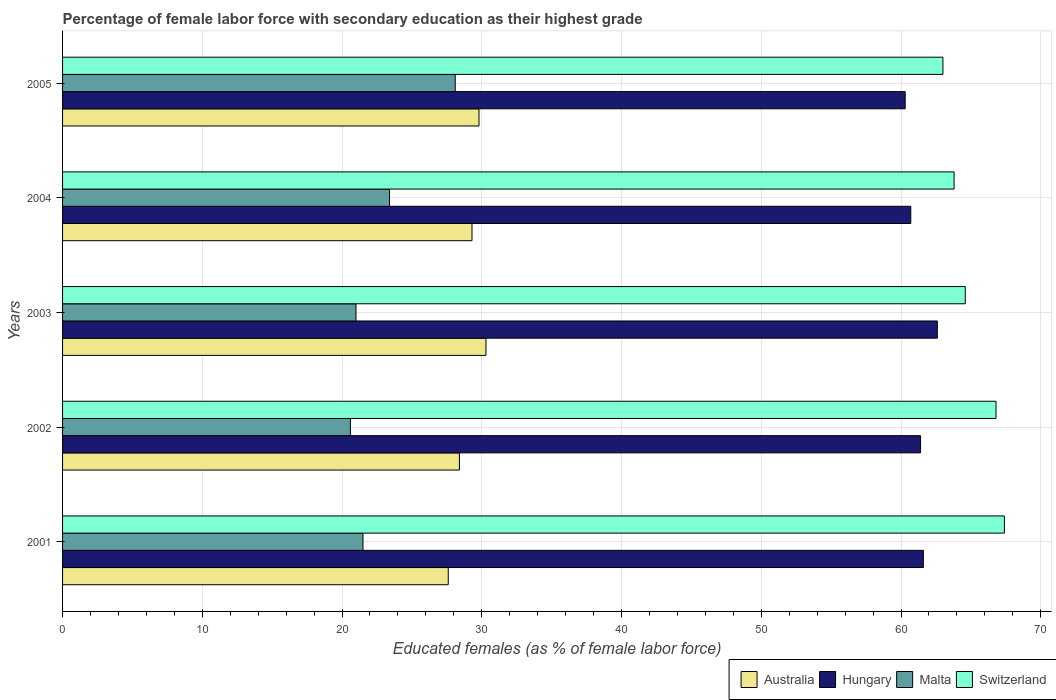Are the number of bars on each tick of the Y-axis equal?
Make the answer very short. Yes. How many bars are there on the 1st tick from the top?
Provide a short and direct response. 4. How many bars are there on the 4th tick from the bottom?
Your response must be concise. 4. What is the percentage of female labor force with secondary education in Hungary in 2005?
Your answer should be compact. 60.3. Across all years, what is the maximum percentage of female labor force with secondary education in Australia?
Make the answer very short. 30.3. In which year was the percentage of female labor force with secondary education in Switzerland maximum?
Ensure brevity in your answer.  2001. What is the total percentage of female labor force with secondary education in Malta in the graph?
Keep it short and to the point. 114.6. What is the difference between the percentage of female labor force with secondary education in Hungary in 2003 and that in 2005?
Your answer should be compact. 2.3. What is the difference between the percentage of female labor force with secondary education in Hungary in 2001 and the percentage of female labor force with secondary education in Australia in 2002?
Offer a terse response. 33.2. What is the average percentage of female labor force with secondary education in Hungary per year?
Provide a short and direct response. 61.32. In the year 2001, what is the difference between the percentage of female labor force with secondary education in Switzerland and percentage of female labor force with secondary education in Australia?
Your answer should be compact. 39.8. What is the ratio of the percentage of female labor force with secondary education in Australia in 2001 to that in 2003?
Offer a terse response. 0.91. Is the difference between the percentage of female labor force with secondary education in Switzerland in 2002 and 2004 greater than the difference between the percentage of female labor force with secondary education in Australia in 2002 and 2004?
Keep it short and to the point. Yes. What is the difference between the highest and the lowest percentage of female labor force with secondary education in Australia?
Make the answer very short. 2.7. In how many years, is the percentage of female labor force with secondary education in Australia greater than the average percentage of female labor force with secondary education in Australia taken over all years?
Your answer should be compact. 3. Is the sum of the percentage of female labor force with secondary education in Switzerland in 2001 and 2005 greater than the maximum percentage of female labor force with secondary education in Australia across all years?
Provide a short and direct response. Yes. Is it the case that in every year, the sum of the percentage of female labor force with secondary education in Hungary and percentage of female labor force with secondary education in Malta is greater than the sum of percentage of female labor force with secondary education in Australia and percentage of female labor force with secondary education in Switzerland?
Provide a short and direct response. Yes. What does the 1st bar from the top in 2003 represents?
Make the answer very short. Switzerland. What does the 4th bar from the bottom in 2005 represents?
Your response must be concise. Switzerland. Is it the case that in every year, the sum of the percentage of female labor force with secondary education in Malta and percentage of female labor force with secondary education in Australia is greater than the percentage of female labor force with secondary education in Hungary?
Ensure brevity in your answer.  No. How many bars are there?
Provide a short and direct response. 20. Are all the bars in the graph horizontal?
Your answer should be very brief. Yes. How many years are there in the graph?
Your answer should be very brief. 5. What is the difference between two consecutive major ticks on the X-axis?
Make the answer very short. 10. Does the graph contain any zero values?
Offer a terse response. No. Where does the legend appear in the graph?
Provide a succinct answer. Bottom right. How many legend labels are there?
Provide a succinct answer. 4. How are the legend labels stacked?
Keep it short and to the point. Horizontal. What is the title of the graph?
Your answer should be compact. Percentage of female labor force with secondary education as their highest grade. Does "New Zealand" appear as one of the legend labels in the graph?
Your answer should be very brief. No. What is the label or title of the X-axis?
Your answer should be compact. Educated females (as % of female labor force). What is the label or title of the Y-axis?
Make the answer very short. Years. What is the Educated females (as % of female labor force) of Australia in 2001?
Offer a very short reply. 27.6. What is the Educated females (as % of female labor force) in Hungary in 2001?
Provide a short and direct response. 61.6. What is the Educated females (as % of female labor force) of Malta in 2001?
Provide a succinct answer. 21.5. What is the Educated females (as % of female labor force) in Switzerland in 2001?
Your answer should be very brief. 67.4. What is the Educated females (as % of female labor force) of Australia in 2002?
Offer a terse response. 28.4. What is the Educated females (as % of female labor force) of Hungary in 2002?
Give a very brief answer. 61.4. What is the Educated females (as % of female labor force) in Malta in 2002?
Your answer should be very brief. 20.6. What is the Educated females (as % of female labor force) of Switzerland in 2002?
Give a very brief answer. 66.8. What is the Educated females (as % of female labor force) in Australia in 2003?
Offer a very short reply. 30.3. What is the Educated females (as % of female labor force) in Hungary in 2003?
Your answer should be compact. 62.6. What is the Educated females (as % of female labor force) in Switzerland in 2003?
Provide a short and direct response. 64.6. What is the Educated females (as % of female labor force) in Australia in 2004?
Keep it short and to the point. 29.3. What is the Educated females (as % of female labor force) of Hungary in 2004?
Your answer should be compact. 60.7. What is the Educated females (as % of female labor force) in Malta in 2004?
Provide a succinct answer. 23.4. What is the Educated females (as % of female labor force) of Switzerland in 2004?
Make the answer very short. 63.8. What is the Educated females (as % of female labor force) in Australia in 2005?
Your response must be concise. 29.8. What is the Educated females (as % of female labor force) of Hungary in 2005?
Offer a terse response. 60.3. What is the Educated females (as % of female labor force) in Malta in 2005?
Offer a very short reply. 28.1. Across all years, what is the maximum Educated females (as % of female labor force) of Australia?
Your response must be concise. 30.3. Across all years, what is the maximum Educated females (as % of female labor force) in Hungary?
Keep it short and to the point. 62.6. Across all years, what is the maximum Educated females (as % of female labor force) of Malta?
Your response must be concise. 28.1. Across all years, what is the maximum Educated females (as % of female labor force) in Switzerland?
Provide a succinct answer. 67.4. Across all years, what is the minimum Educated females (as % of female labor force) in Australia?
Keep it short and to the point. 27.6. Across all years, what is the minimum Educated females (as % of female labor force) in Hungary?
Make the answer very short. 60.3. Across all years, what is the minimum Educated females (as % of female labor force) of Malta?
Make the answer very short. 20.6. What is the total Educated females (as % of female labor force) in Australia in the graph?
Your response must be concise. 145.4. What is the total Educated females (as % of female labor force) of Hungary in the graph?
Offer a very short reply. 306.6. What is the total Educated females (as % of female labor force) in Malta in the graph?
Give a very brief answer. 114.6. What is the total Educated females (as % of female labor force) of Switzerland in the graph?
Provide a short and direct response. 325.6. What is the difference between the Educated females (as % of female labor force) of Australia in 2001 and that in 2002?
Keep it short and to the point. -0.8. What is the difference between the Educated females (as % of female labor force) in Hungary in 2001 and that in 2002?
Provide a succinct answer. 0.2. What is the difference between the Educated females (as % of female labor force) in Malta in 2001 and that in 2002?
Give a very brief answer. 0.9. What is the difference between the Educated females (as % of female labor force) of Australia in 2001 and that in 2003?
Keep it short and to the point. -2.7. What is the difference between the Educated females (as % of female labor force) in Switzerland in 2001 and that in 2003?
Your answer should be very brief. 2.8. What is the difference between the Educated females (as % of female labor force) of Australia in 2001 and that in 2004?
Offer a very short reply. -1.7. What is the difference between the Educated females (as % of female labor force) of Australia in 2001 and that in 2005?
Your response must be concise. -2.2. What is the difference between the Educated females (as % of female labor force) in Malta in 2001 and that in 2005?
Your answer should be compact. -6.6. What is the difference between the Educated females (as % of female labor force) of Australia in 2002 and that in 2003?
Your answer should be very brief. -1.9. What is the difference between the Educated females (as % of female labor force) in Hungary in 2002 and that in 2003?
Ensure brevity in your answer.  -1.2. What is the difference between the Educated females (as % of female labor force) of Switzerland in 2002 and that in 2003?
Provide a succinct answer. 2.2. What is the difference between the Educated females (as % of female labor force) of Hungary in 2002 and that in 2004?
Give a very brief answer. 0.7. What is the difference between the Educated females (as % of female labor force) in Malta in 2002 and that in 2004?
Make the answer very short. -2.8. What is the difference between the Educated females (as % of female labor force) in Malta in 2002 and that in 2005?
Offer a terse response. -7.5. What is the difference between the Educated females (as % of female labor force) in Switzerland in 2003 and that in 2005?
Provide a short and direct response. 1.6. What is the difference between the Educated females (as % of female labor force) of Australia in 2004 and that in 2005?
Keep it short and to the point. -0.5. What is the difference between the Educated females (as % of female labor force) in Switzerland in 2004 and that in 2005?
Offer a very short reply. 0.8. What is the difference between the Educated females (as % of female labor force) of Australia in 2001 and the Educated females (as % of female labor force) of Hungary in 2002?
Ensure brevity in your answer.  -33.8. What is the difference between the Educated females (as % of female labor force) in Australia in 2001 and the Educated females (as % of female labor force) in Malta in 2002?
Make the answer very short. 7. What is the difference between the Educated females (as % of female labor force) of Australia in 2001 and the Educated females (as % of female labor force) of Switzerland in 2002?
Offer a terse response. -39.2. What is the difference between the Educated females (as % of female labor force) of Hungary in 2001 and the Educated females (as % of female labor force) of Malta in 2002?
Your answer should be compact. 41. What is the difference between the Educated females (as % of female labor force) in Hungary in 2001 and the Educated females (as % of female labor force) in Switzerland in 2002?
Keep it short and to the point. -5.2. What is the difference between the Educated females (as % of female labor force) in Malta in 2001 and the Educated females (as % of female labor force) in Switzerland in 2002?
Your answer should be very brief. -45.3. What is the difference between the Educated females (as % of female labor force) in Australia in 2001 and the Educated females (as % of female labor force) in Hungary in 2003?
Ensure brevity in your answer.  -35. What is the difference between the Educated females (as % of female labor force) in Australia in 2001 and the Educated females (as % of female labor force) in Switzerland in 2003?
Make the answer very short. -37. What is the difference between the Educated females (as % of female labor force) of Hungary in 2001 and the Educated females (as % of female labor force) of Malta in 2003?
Provide a short and direct response. 40.6. What is the difference between the Educated females (as % of female labor force) in Malta in 2001 and the Educated females (as % of female labor force) in Switzerland in 2003?
Your answer should be compact. -43.1. What is the difference between the Educated females (as % of female labor force) of Australia in 2001 and the Educated females (as % of female labor force) of Hungary in 2004?
Provide a short and direct response. -33.1. What is the difference between the Educated females (as % of female labor force) of Australia in 2001 and the Educated females (as % of female labor force) of Malta in 2004?
Offer a terse response. 4.2. What is the difference between the Educated females (as % of female labor force) of Australia in 2001 and the Educated females (as % of female labor force) of Switzerland in 2004?
Your answer should be compact. -36.2. What is the difference between the Educated females (as % of female labor force) of Hungary in 2001 and the Educated females (as % of female labor force) of Malta in 2004?
Offer a very short reply. 38.2. What is the difference between the Educated females (as % of female labor force) in Malta in 2001 and the Educated females (as % of female labor force) in Switzerland in 2004?
Offer a terse response. -42.3. What is the difference between the Educated females (as % of female labor force) of Australia in 2001 and the Educated females (as % of female labor force) of Hungary in 2005?
Provide a succinct answer. -32.7. What is the difference between the Educated females (as % of female labor force) in Australia in 2001 and the Educated females (as % of female labor force) in Switzerland in 2005?
Offer a terse response. -35.4. What is the difference between the Educated females (as % of female labor force) of Hungary in 2001 and the Educated females (as % of female labor force) of Malta in 2005?
Provide a short and direct response. 33.5. What is the difference between the Educated females (as % of female labor force) in Malta in 2001 and the Educated females (as % of female labor force) in Switzerland in 2005?
Provide a short and direct response. -41.5. What is the difference between the Educated females (as % of female labor force) of Australia in 2002 and the Educated females (as % of female labor force) of Hungary in 2003?
Provide a short and direct response. -34.2. What is the difference between the Educated females (as % of female labor force) of Australia in 2002 and the Educated females (as % of female labor force) of Switzerland in 2003?
Your response must be concise. -36.2. What is the difference between the Educated females (as % of female labor force) of Hungary in 2002 and the Educated females (as % of female labor force) of Malta in 2003?
Offer a terse response. 40.4. What is the difference between the Educated females (as % of female labor force) in Hungary in 2002 and the Educated females (as % of female labor force) in Switzerland in 2003?
Offer a terse response. -3.2. What is the difference between the Educated females (as % of female labor force) of Malta in 2002 and the Educated females (as % of female labor force) of Switzerland in 2003?
Provide a succinct answer. -44. What is the difference between the Educated females (as % of female labor force) in Australia in 2002 and the Educated females (as % of female labor force) in Hungary in 2004?
Make the answer very short. -32.3. What is the difference between the Educated females (as % of female labor force) in Australia in 2002 and the Educated females (as % of female labor force) in Malta in 2004?
Make the answer very short. 5. What is the difference between the Educated females (as % of female labor force) of Australia in 2002 and the Educated females (as % of female labor force) of Switzerland in 2004?
Your answer should be compact. -35.4. What is the difference between the Educated females (as % of female labor force) of Hungary in 2002 and the Educated females (as % of female labor force) of Switzerland in 2004?
Make the answer very short. -2.4. What is the difference between the Educated females (as % of female labor force) of Malta in 2002 and the Educated females (as % of female labor force) of Switzerland in 2004?
Keep it short and to the point. -43.2. What is the difference between the Educated females (as % of female labor force) of Australia in 2002 and the Educated females (as % of female labor force) of Hungary in 2005?
Your answer should be compact. -31.9. What is the difference between the Educated females (as % of female labor force) of Australia in 2002 and the Educated females (as % of female labor force) of Malta in 2005?
Keep it short and to the point. 0.3. What is the difference between the Educated females (as % of female labor force) of Australia in 2002 and the Educated females (as % of female labor force) of Switzerland in 2005?
Your response must be concise. -34.6. What is the difference between the Educated females (as % of female labor force) in Hungary in 2002 and the Educated females (as % of female labor force) in Malta in 2005?
Provide a succinct answer. 33.3. What is the difference between the Educated females (as % of female labor force) in Hungary in 2002 and the Educated females (as % of female labor force) in Switzerland in 2005?
Your response must be concise. -1.6. What is the difference between the Educated females (as % of female labor force) of Malta in 2002 and the Educated females (as % of female labor force) of Switzerland in 2005?
Provide a succinct answer. -42.4. What is the difference between the Educated females (as % of female labor force) in Australia in 2003 and the Educated females (as % of female labor force) in Hungary in 2004?
Offer a terse response. -30.4. What is the difference between the Educated females (as % of female labor force) in Australia in 2003 and the Educated females (as % of female labor force) in Switzerland in 2004?
Ensure brevity in your answer.  -33.5. What is the difference between the Educated females (as % of female labor force) in Hungary in 2003 and the Educated females (as % of female labor force) in Malta in 2004?
Offer a very short reply. 39.2. What is the difference between the Educated females (as % of female labor force) of Hungary in 2003 and the Educated females (as % of female labor force) of Switzerland in 2004?
Your response must be concise. -1.2. What is the difference between the Educated females (as % of female labor force) in Malta in 2003 and the Educated females (as % of female labor force) in Switzerland in 2004?
Keep it short and to the point. -42.8. What is the difference between the Educated females (as % of female labor force) in Australia in 2003 and the Educated females (as % of female labor force) in Switzerland in 2005?
Offer a terse response. -32.7. What is the difference between the Educated females (as % of female labor force) in Hungary in 2003 and the Educated females (as % of female labor force) in Malta in 2005?
Make the answer very short. 34.5. What is the difference between the Educated females (as % of female labor force) of Malta in 2003 and the Educated females (as % of female labor force) of Switzerland in 2005?
Provide a succinct answer. -42. What is the difference between the Educated females (as % of female labor force) in Australia in 2004 and the Educated females (as % of female labor force) in Hungary in 2005?
Ensure brevity in your answer.  -31. What is the difference between the Educated females (as % of female labor force) of Australia in 2004 and the Educated females (as % of female labor force) of Switzerland in 2005?
Your answer should be compact. -33.7. What is the difference between the Educated females (as % of female labor force) in Hungary in 2004 and the Educated females (as % of female labor force) in Malta in 2005?
Offer a very short reply. 32.6. What is the difference between the Educated females (as % of female labor force) of Hungary in 2004 and the Educated females (as % of female labor force) of Switzerland in 2005?
Give a very brief answer. -2.3. What is the difference between the Educated females (as % of female labor force) in Malta in 2004 and the Educated females (as % of female labor force) in Switzerland in 2005?
Provide a succinct answer. -39.6. What is the average Educated females (as % of female labor force) in Australia per year?
Your response must be concise. 29.08. What is the average Educated females (as % of female labor force) of Hungary per year?
Offer a very short reply. 61.32. What is the average Educated females (as % of female labor force) of Malta per year?
Your answer should be compact. 22.92. What is the average Educated females (as % of female labor force) of Switzerland per year?
Offer a very short reply. 65.12. In the year 2001, what is the difference between the Educated females (as % of female labor force) of Australia and Educated females (as % of female labor force) of Hungary?
Provide a succinct answer. -34. In the year 2001, what is the difference between the Educated females (as % of female labor force) of Australia and Educated females (as % of female labor force) of Switzerland?
Make the answer very short. -39.8. In the year 2001, what is the difference between the Educated females (as % of female labor force) in Hungary and Educated females (as % of female labor force) in Malta?
Your answer should be compact. 40.1. In the year 2001, what is the difference between the Educated females (as % of female labor force) in Hungary and Educated females (as % of female labor force) in Switzerland?
Your answer should be compact. -5.8. In the year 2001, what is the difference between the Educated females (as % of female labor force) of Malta and Educated females (as % of female labor force) of Switzerland?
Your answer should be very brief. -45.9. In the year 2002, what is the difference between the Educated females (as % of female labor force) of Australia and Educated females (as % of female labor force) of Hungary?
Give a very brief answer. -33. In the year 2002, what is the difference between the Educated females (as % of female labor force) of Australia and Educated females (as % of female labor force) of Switzerland?
Offer a terse response. -38.4. In the year 2002, what is the difference between the Educated females (as % of female labor force) of Hungary and Educated females (as % of female labor force) of Malta?
Your response must be concise. 40.8. In the year 2002, what is the difference between the Educated females (as % of female labor force) in Malta and Educated females (as % of female labor force) in Switzerland?
Offer a terse response. -46.2. In the year 2003, what is the difference between the Educated females (as % of female labor force) in Australia and Educated females (as % of female labor force) in Hungary?
Your answer should be very brief. -32.3. In the year 2003, what is the difference between the Educated females (as % of female labor force) of Australia and Educated females (as % of female labor force) of Switzerland?
Make the answer very short. -34.3. In the year 2003, what is the difference between the Educated females (as % of female labor force) of Hungary and Educated females (as % of female labor force) of Malta?
Ensure brevity in your answer.  41.6. In the year 2003, what is the difference between the Educated females (as % of female labor force) of Malta and Educated females (as % of female labor force) of Switzerland?
Your response must be concise. -43.6. In the year 2004, what is the difference between the Educated females (as % of female labor force) of Australia and Educated females (as % of female labor force) of Hungary?
Provide a short and direct response. -31.4. In the year 2004, what is the difference between the Educated females (as % of female labor force) of Australia and Educated females (as % of female labor force) of Switzerland?
Keep it short and to the point. -34.5. In the year 2004, what is the difference between the Educated females (as % of female labor force) in Hungary and Educated females (as % of female labor force) in Malta?
Offer a terse response. 37.3. In the year 2004, what is the difference between the Educated females (as % of female labor force) in Hungary and Educated females (as % of female labor force) in Switzerland?
Your response must be concise. -3.1. In the year 2004, what is the difference between the Educated females (as % of female labor force) in Malta and Educated females (as % of female labor force) in Switzerland?
Provide a succinct answer. -40.4. In the year 2005, what is the difference between the Educated females (as % of female labor force) of Australia and Educated females (as % of female labor force) of Hungary?
Your answer should be very brief. -30.5. In the year 2005, what is the difference between the Educated females (as % of female labor force) in Australia and Educated females (as % of female labor force) in Malta?
Your answer should be compact. 1.7. In the year 2005, what is the difference between the Educated females (as % of female labor force) in Australia and Educated females (as % of female labor force) in Switzerland?
Offer a very short reply. -33.2. In the year 2005, what is the difference between the Educated females (as % of female labor force) of Hungary and Educated females (as % of female labor force) of Malta?
Provide a succinct answer. 32.2. In the year 2005, what is the difference between the Educated females (as % of female labor force) in Hungary and Educated females (as % of female labor force) in Switzerland?
Give a very brief answer. -2.7. In the year 2005, what is the difference between the Educated females (as % of female labor force) in Malta and Educated females (as % of female labor force) in Switzerland?
Your answer should be very brief. -34.9. What is the ratio of the Educated females (as % of female labor force) of Australia in 2001 to that in 2002?
Give a very brief answer. 0.97. What is the ratio of the Educated females (as % of female labor force) of Hungary in 2001 to that in 2002?
Give a very brief answer. 1. What is the ratio of the Educated females (as % of female labor force) of Malta in 2001 to that in 2002?
Your answer should be compact. 1.04. What is the ratio of the Educated females (as % of female labor force) of Switzerland in 2001 to that in 2002?
Provide a succinct answer. 1.01. What is the ratio of the Educated females (as % of female labor force) in Australia in 2001 to that in 2003?
Your response must be concise. 0.91. What is the ratio of the Educated females (as % of female labor force) in Hungary in 2001 to that in 2003?
Offer a terse response. 0.98. What is the ratio of the Educated females (as % of female labor force) in Malta in 2001 to that in 2003?
Your response must be concise. 1.02. What is the ratio of the Educated females (as % of female labor force) of Switzerland in 2001 to that in 2003?
Offer a very short reply. 1.04. What is the ratio of the Educated females (as % of female labor force) in Australia in 2001 to that in 2004?
Keep it short and to the point. 0.94. What is the ratio of the Educated females (as % of female labor force) in Hungary in 2001 to that in 2004?
Make the answer very short. 1.01. What is the ratio of the Educated females (as % of female labor force) in Malta in 2001 to that in 2004?
Provide a short and direct response. 0.92. What is the ratio of the Educated females (as % of female labor force) of Switzerland in 2001 to that in 2004?
Your response must be concise. 1.06. What is the ratio of the Educated females (as % of female labor force) of Australia in 2001 to that in 2005?
Provide a short and direct response. 0.93. What is the ratio of the Educated females (as % of female labor force) of Hungary in 2001 to that in 2005?
Ensure brevity in your answer.  1.02. What is the ratio of the Educated females (as % of female labor force) of Malta in 2001 to that in 2005?
Provide a short and direct response. 0.77. What is the ratio of the Educated females (as % of female labor force) of Switzerland in 2001 to that in 2005?
Your answer should be very brief. 1.07. What is the ratio of the Educated females (as % of female labor force) of Australia in 2002 to that in 2003?
Make the answer very short. 0.94. What is the ratio of the Educated females (as % of female labor force) of Hungary in 2002 to that in 2003?
Offer a terse response. 0.98. What is the ratio of the Educated females (as % of female labor force) in Switzerland in 2002 to that in 2003?
Keep it short and to the point. 1.03. What is the ratio of the Educated females (as % of female labor force) of Australia in 2002 to that in 2004?
Your answer should be very brief. 0.97. What is the ratio of the Educated females (as % of female labor force) in Hungary in 2002 to that in 2004?
Offer a very short reply. 1.01. What is the ratio of the Educated females (as % of female labor force) of Malta in 2002 to that in 2004?
Ensure brevity in your answer.  0.88. What is the ratio of the Educated females (as % of female labor force) in Switzerland in 2002 to that in 2004?
Keep it short and to the point. 1.05. What is the ratio of the Educated females (as % of female labor force) of Australia in 2002 to that in 2005?
Ensure brevity in your answer.  0.95. What is the ratio of the Educated females (as % of female labor force) in Hungary in 2002 to that in 2005?
Your answer should be compact. 1.02. What is the ratio of the Educated females (as % of female labor force) of Malta in 2002 to that in 2005?
Give a very brief answer. 0.73. What is the ratio of the Educated females (as % of female labor force) in Switzerland in 2002 to that in 2005?
Offer a terse response. 1.06. What is the ratio of the Educated females (as % of female labor force) in Australia in 2003 to that in 2004?
Keep it short and to the point. 1.03. What is the ratio of the Educated females (as % of female labor force) in Hungary in 2003 to that in 2004?
Offer a terse response. 1.03. What is the ratio of the Educated females (as % of female labor force) in Malta in 2003 to that in 2004?
Offer a very short reply. 0.9. What is the ratio of the Educated females (as % of female labor force) in Switzerland in 2003 to that in 2004?
Make the answer very short. 1.01. What is the ratio of the Educated females (as % of female labor force) of Australia in 2003 to that in 2005?
Give a very brief answer. 1.02. What is the ratio of the Educated females (as % of female labor force) of Hungary in 2003 to that in 2005?
Provide a short and direct response. 1.04. What is the ratio of the Educated females (as % of female labor force) in Malta in 2003 to that in 2005?
Make the answer very short. 0.75. What is the ratio of the Educated females (as % of female labor force) in Switzerland in 2003 to that in 2005?
Ensure brevity in your answer.  1.03. What is the ratio of the Educated females (as % of female labor force) in Australia in 2004 to that in 2005?
Give a very brief answer. 0.98. What is the ratio of the Educated females (as % of female labor force) in Hungary in 2004 to that in 2005?
Keep it short and to the point. 1.01. What is the ratio of the Educated females (as % of female labor force) of Malta in 2004 to that in 2005?
Ensure brevity in your answer.  0.83. What is the ratio of the Educated females (as % of female labor force) in Switzerland in 2004 to that in 2005?
Make the answer very short. 1.01. What is the difference between the highest and the second highest Educated females (as % of female labor force) of Hungary?
Offer a very short reply. 1. What is the difference between the highest and the second highest Educated females (as % of female labor force) in Malta?
Make the answer very short. 4.7. What is the difference between the highest and the lowest Educated females (as % of female labor force) of Australia?
Offer a terse response. 2.7. What is the difference between the highest and the lowest Educated females (as % of female labor force) of Malta?
Keep it short and to the point. 7.5. 